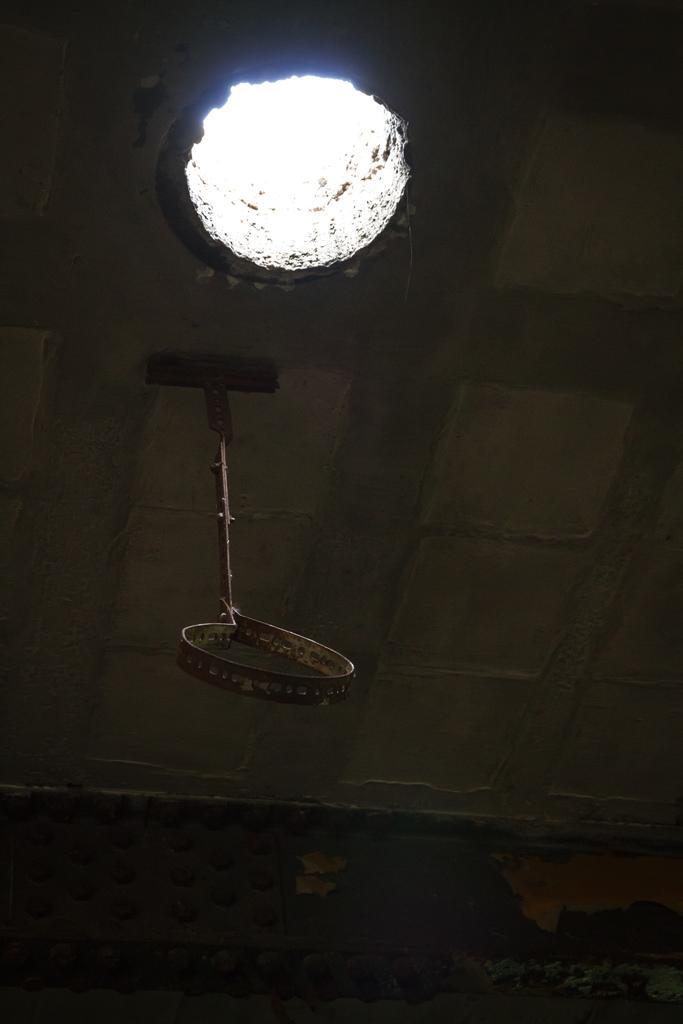Describe this image in one or two sentences. In this image there is an object hangs from the ceiling and there's a hole. 